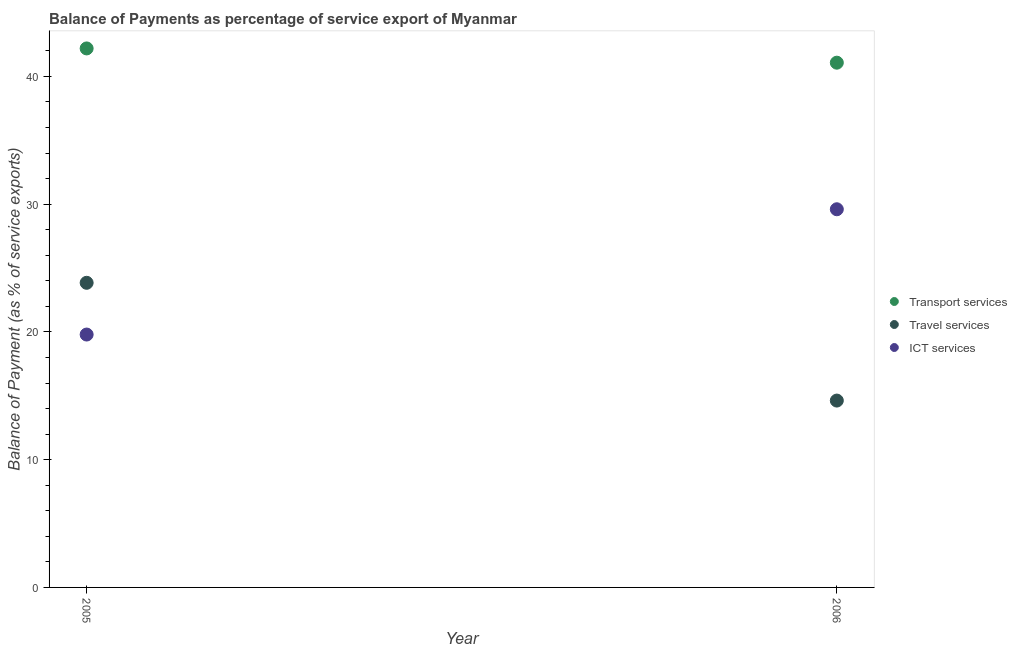How many different coloured dotlines are there?
Your response must be concise. 3. What is the balance of payment of ict services in 2005?
Offer a terse response. 19.79. Across all years, what is the maximum balance of payment of travel services?
Ensure brevity in your answer.  23.85. Across all years, what is the minimum balance of payment of transport services?
Your answer should be compact. 41.08. In which year was the balance of payment of transport services maximum?
Offer a terse response. 2005. What is the total balance of payment of ict services in the graph?
Ensure brevity in your answer.  49.4. What is the difference between the balance of payment of travel services in 2005 and that in 2006?
Your response must be concise. 9.22. What is the difference between the balance of payment of transport services in 2006 and the balance of payment of travel services in 2005?
Offer a terse response. 17.23. What is the average balance of payment of travel services per year?
Give a very brief answer. 19.24. In the year 2005, what is the difference between the balance of payment of travel services and balance of payment of ict services?
Make the answer very short. 4.05. In how many years, is the balance of payment of travel services greater than 28 %?
Keep it short and to the point. 0. What is the ratio of the balance of payment of transport services in 2005 to that in 2006?
Keep it short and to the point. 1.03. In how many years, is the balance of payment of ict services greater than the average balance of payment of ict services taken over all years?
Offer a terse response. 1. How many dotlines are there?
Keep it short and to the point. 3. How many years are there in the graph?
Give a very brief answer. 2. What is the difference between two consecutive major ticks on the Y-axis?
Your response must be concise. 10. Does the graph contain any zero values?
Your answer should be compact. No. Where does the legend appear in the graph?
Make the answer very short. Center right. What is the title of the graph?
Your answer should be very brief. Balance of Payments as percentage of service export of Myanmar. Does "Total employers" appear as one of the legend labels in the graph?
Make the answer very short. No. What is the label or title of the X-axis?
Keep it short and to the point. Year. What is the label or title of the Y-axis?
Provide a succinct answer. Balance of Payment (as % of service exports). What is the Balance of Payment (as % of service exports) of Transport services in 2005?
Your answer should be very brief. 42.19. What is the Balance of Payment (as % of service exports) in Travel services in 2005?
Give a very brief answer. 23.85. What is the Balance of Payment (as % of service exports) of ICT services in 2005?
Make the answer very short. 19.79. What is the Balance of Payment (as % of service exports) of Transport services in 2006?
Provide a succinct answer. 41.08. What is the Balance of Payment (as % of service exports) in Travel services in 2006?
Your answer should be compact. 14.63. What is the Balance of Payment (as % of service exports) of ICT services in 2006?
Provide a succinct answer. 29.6. Across all years, what is the maximum Balance of Payment (as % of service exports) of Transport services?
Your answer should be compact. 42.19. Across all years, what is the maximum Balance of Payment (as % of service exports) in Travel services?
Your answer should be very brief. 23.85. Across all years, what is the maximum Balance of Payment (as % of service exports) in ICT services?
Ensure brevity in your answer.  29.6. Across all years, what is the minimum Balance of Payment (as % of service exports) of Transport services?
Offer a terse response. 41.08. Across all years, what is the minimum Balance of Payment (as % of service exports) of Travel services?
Ensure brevity in your answer.  14.63. Across all years, what is the minimum Balance of Payment (as % of service exports) in ICT services?
Your answer should be compact. 19.79. What is the total Balance of Payment (as % of service exports) of Transport services in the graph?
Make the answer very short. 83.27. What is the total Balance of Payment (as % of service exports) in Travel services in the graph?
Your answer should be compact. 38.47. What is the total Balance of Payment (as % of service exports) of ICT services in the graph?
Keep it short and to the point. 49.4. What is the difference between the Balance of Payment (as % of service exports) of Transport services in 2005 and that in 2006?
Offer a terse response. 1.12. What is the difference between the Balance of Payment (as % of service exports) in Travel services in 2005 and that in 2006?
Your answer should be compact. 9.22. What is the difference between the Balance of Payment (as % of service exports) of ICT services in 2005 and that in 2006?
Ensure brevity in your answer.  -9.81. What is the difference between the Balance of Payment (as % of service exports) of Transport services in 2005 and the Balance of Payment (as % of service exports) of Travel services in 2006?
Provide a succinct answer. 27.56. What is the difference between the Balance of Payment (as % of service exports) in Transport services in 2005 and the Balance of Payment (as % of service exports) in ICT services in 2006?
Your answer should be compact. 12.59. What is the difference between the Balance of Payment (as % of service exports) in Travel services in 2005 and the Balance of Payment (as % of service exports) in ICT services in 2006?
Your answer should be very brief. -5.76. What is the average Balance of Payment (as % of service exports) in Transport services per year?
Provide a short and direct response. 41.63. What is the average Balance of Payment (as % of service exports) of Travel services per year?
Provide a short and direct response. 19.24. What is the average Balance of Payment (as % of service exports) of ICT services per year?
Provide a succinct answer. 24.7. In the year 2005, what is the difference between the Balance of Payment (as % of service exports) of Transport services and Balance of Payment (as % of service exports) of Travel services?
Your response must be concise. 18.35. In the year 2005, what is the difference between the Balance of Payment (as % of service exports) of Transport services and Balance of Payment (as % of service exports) of ICT services?
Give a very brief answer. 22.4. In the year 2005, what is the difference between the Balance of Payment (as % of service exports) in Travel services and Balance of Payment (as % of service exports) in ICT services?
Provide a succinct answer. 4.05. In the year 2006, what is the difference between the Balance of Payment (as % of service exports) of Transport services and Balance of Payment (as % of service exports) of Travel services?
Offer a terse response. 26.45. In the year 2006, what is the difference between the Balance of Payment (as % of service exports) of Transport services and Balance of Payment (as % of service exports) of ICT services?
Provide a succinct answer. 11.47. In the year 2006, what is the difference between the Balance of Payment (as % of service exports) in Travel services and Balance of Payment (as % of service exports) in ICT services?
Your answer should be very brief. -14.98. What is the ratio of the Balance of Payment (as % of service exports) of Transport services in 2005 to that in 2006?
Keep it short and to the point. 1.03. What is the ratio of the Balance of Payment (as % of service exports) of Travel services in 2005 to that in 2006?
Offer a terse response. 1.63. What is the ratio of the Balance of Payment (as % of service exports) of ICT services in 2005 to that in 2006?
Give a very brief answer. 0.67. What is the difference between the highest and the second highest Balance of Payment (as % of service exports) of Transport services?
Make the answer very short. 1.12. What is the difference between the highest and the second highest Balance of Payment (as % of service exports) in Travel services?
Your answer should be compact. 9.22. What is the difference between the highest and the second highest Balance of Payment (as % of service exports) in ICT services?
Give a very brief answer. 9.81. What is the difference between the highest and the lowest Balance of Payment (as % of service exports) in Transport services?
Ensure brevity in your answer.  1.12. What is the difference between the highest and the lowest Balance of Payment (as % of service exports) in Travel services?
Offer a very short reply. 9.22. What is the difference between the highest and the lowest Balance of Payment (as % of service exports) in ICT services?
Give a very brief answer. 9.81. 